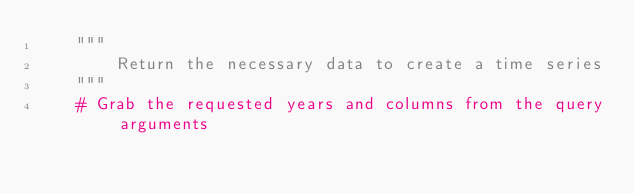<code> <loc_0><loc_0><loc_500><loc_500><_Python_>    """
        Return the necessary data to create a time series
    """
    # Grab the requested years and columns from the query arguments</code> 